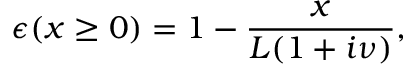Convert formula to latex. <formula><loc_0><loc_0><loc_500><loc_500>\epsilon ( x \geq 0 ) = 1 - \frac { x } { L ( 1 + i \nu ) } ,</formula> 